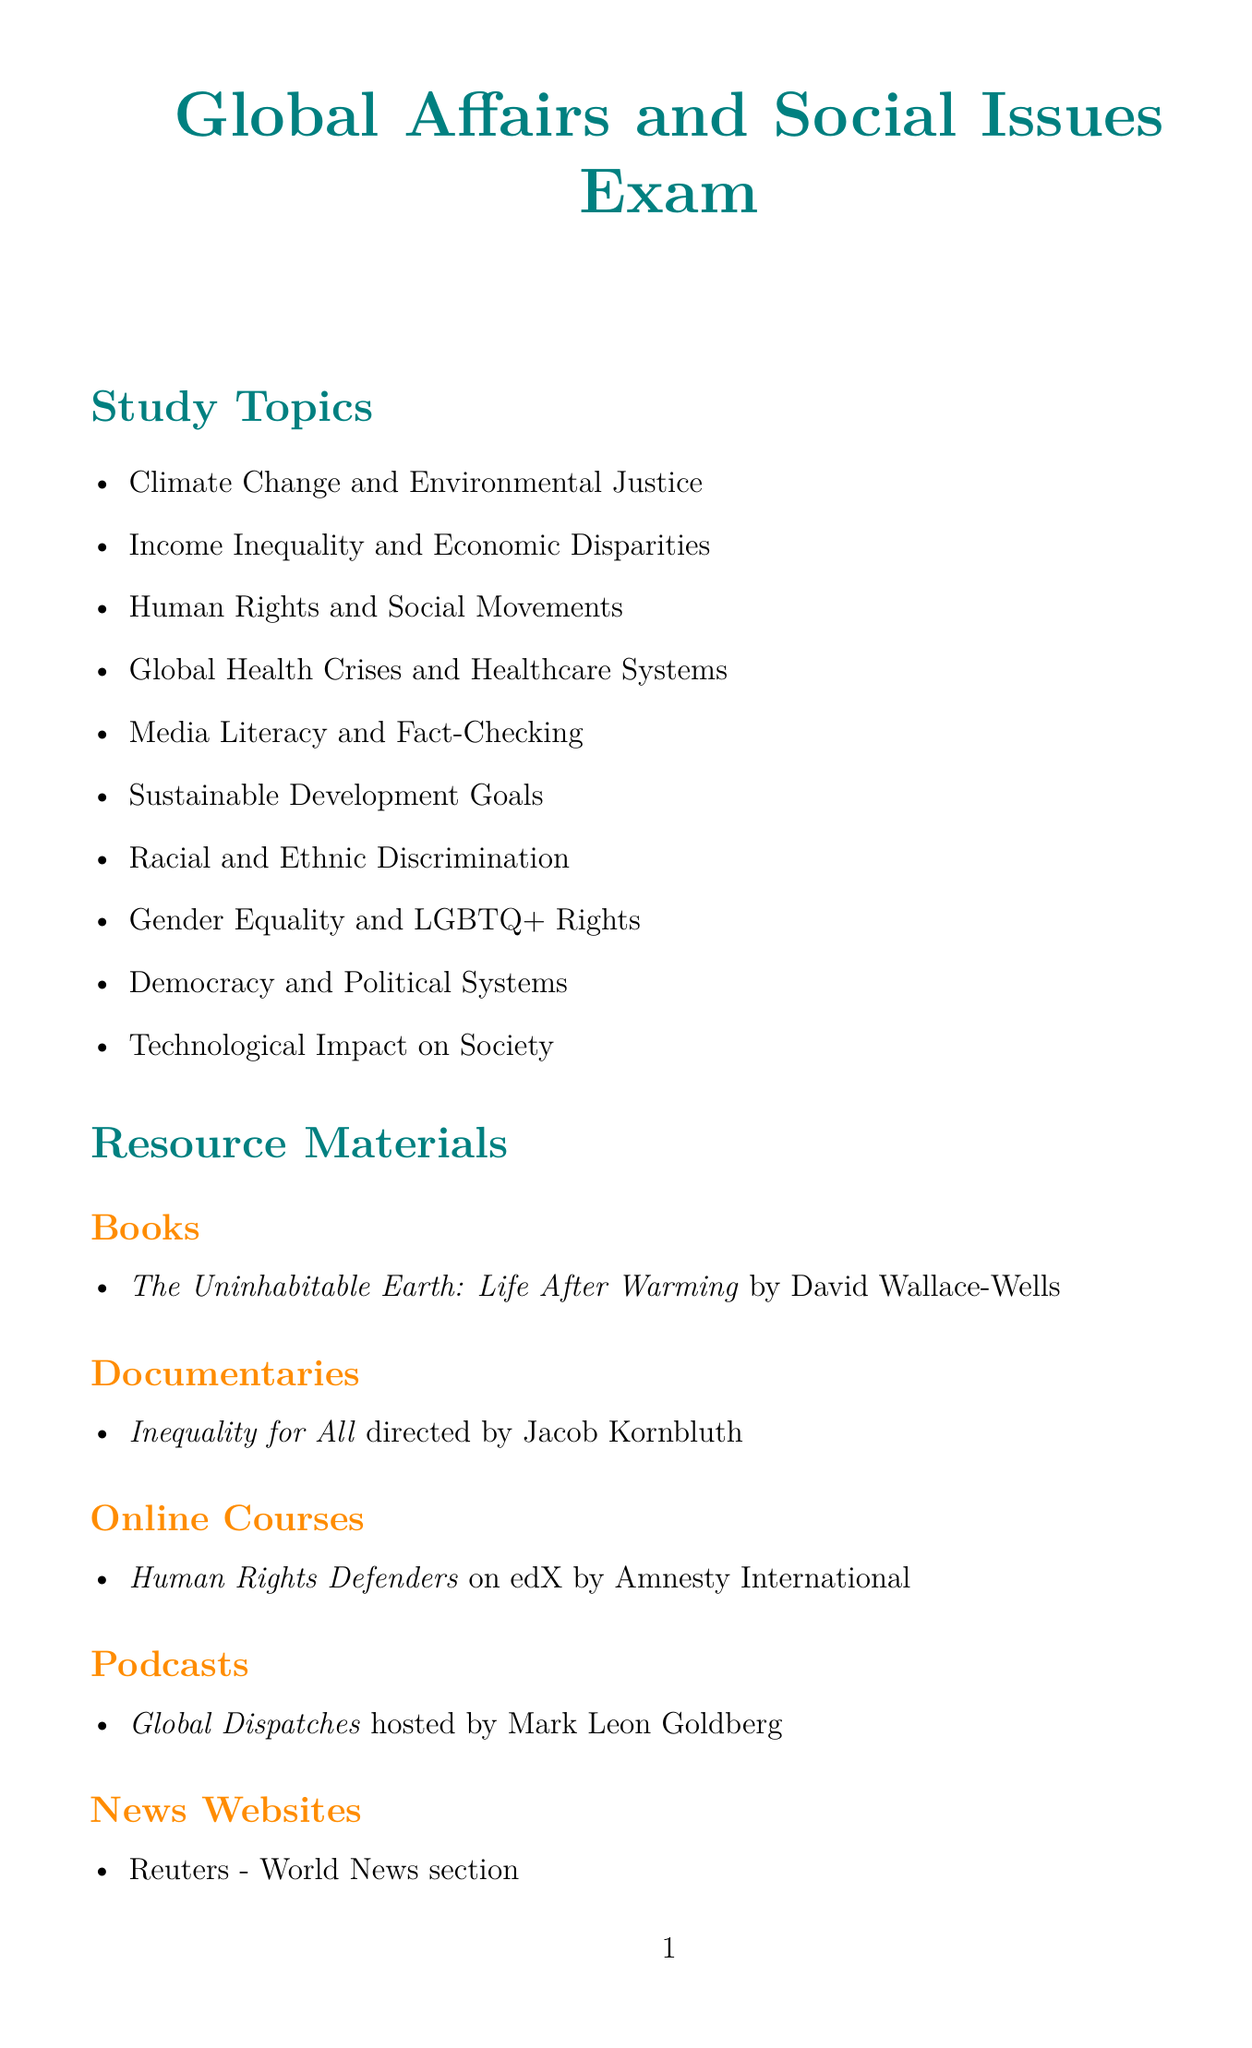what is the name of the exam? The exam is focused on Global Affairs and Social Issues, as stated at the beginning of the document.
Answer: Global Affairs and Social Issues Exam what is the date of the practice test focused on Political Systems and Social Movements? The document lists the date for this practice test, which is found in the Practice Test Dates section.
Answer: November 5, 2023 who is the author of the book "The Uninhabitable Earth: Life After Warming"? The document includes the author's name in the Resource Materials section under Books.
Answer: David Wallace-Wells which organization provided the Online Course "Human Rights Defenders"? The provider is mentioned alongside the course details in the Resource Materials section.
Answer: Amnesty International how often does the Global Thinkers Club meet? The schedule specifies the meeting day of the Global Thinkers Club, indicating how often it occurs.
Answer: Tuesdays what is the focus of the additional resource "NPR News"? The document describes the purpose of this news app in the Additional Resources section.
Answer: Daily global news updates name one TED Talk mentioned in the document. The document lists different types of resource materials including TED Talks.
Answer: The danger of a single story what is the meeting location for the Youth for Social Change study group? The location is provided alongside the details of the study group in the Study Groups section.
Answer: Community Center 